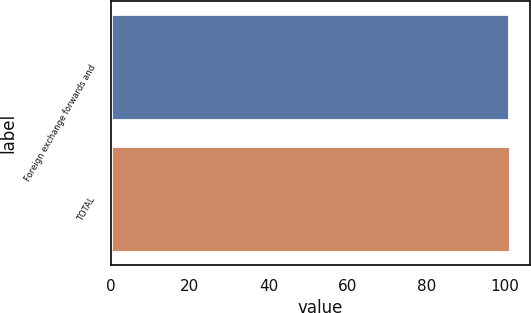<chart> <loc_0><loc_0><loc_500><loc_500><bar_chart><fcel>Foreign exchange forwards and<fcel>TOTAL<nl><fcel>101<fcel>101.1<nl></chart> 